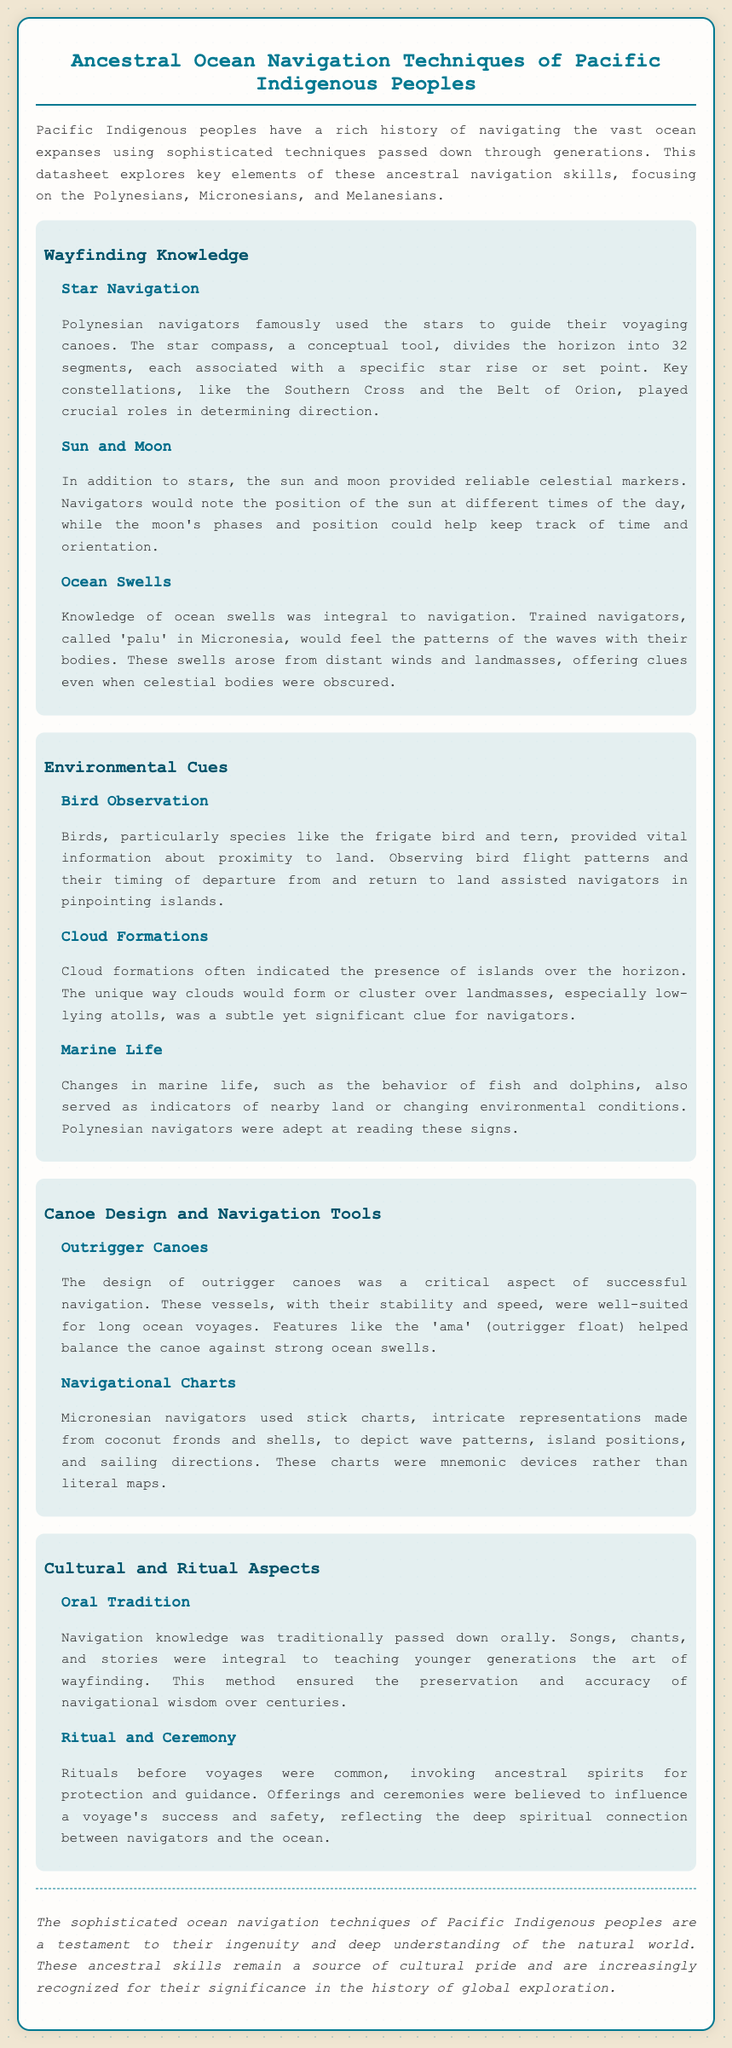what are the three main regions of Pacific Indigenous navigation? The document mentions Polynesians, Micronesians, and Melanesians as the three key regions of navigation.
Answer: Polynesians, Micronesians, and Melanesians what is the tool used by Polynesian navigators for star guidance? The document describes the star compass as a conceptual tool used by Polynesian navigators.
Answer: star compass which celestial bodies guide navigation besides stars? According to the document, the sun and moon also serve as reliable markers for navigation.
Answer: sun and moon what is the term for trained navigators in Micronesia? The document references 'palu' as the term for trained navigators in Micronesia.
Answer: palu what do stick charts represent in Micronesian navigation? Stick charts visually depict wave patterns, island positions, and sailing directions, as stated in the document.
Answer: wave patterns, island positions, and sailing directions how is navigation knowledge traditionally passed down? The document explains that navigation knowledge was passed down orally through songs, chants, and stories.
Answer: orally what is an outrigger canoe designed for? The document mentions that outrigger canoes were designed for stability and speed during long ocean voyages.
Answer: stability and speed what role do bird observations play in navigation? According to the document, bird observations help navigators determine proximity to land.
Answer: determine proximity to land what cultural activity precedes a voyage? The document notes that rituals before voyages often involved invoking ancestral spirits for guidance.
Answer: invoking ancestral spirits for guidance 